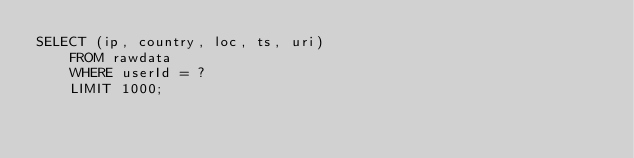<code> <loc_0><loc_0><loc_500><loc_500><_SQL_>SELECT (ip, country, loc, ts, uri)
    FROM rawdata
    WHERE userId = ?
    LIMIT 1000;
</code> 